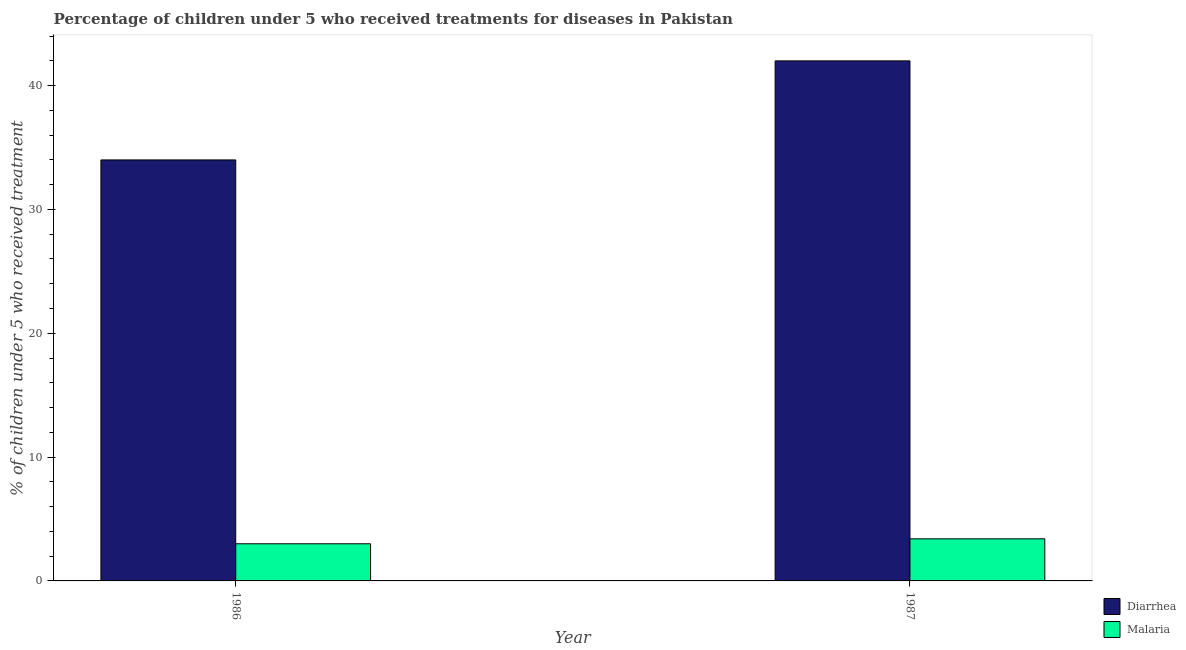Are the number of bars per tick equal to the number of legend labels?
Your answer should be very brief. Yes. Are the number of bars on each tick of the X-axis equal?
Your response must be concise. Yes. What is the label of the 2nd group of bars from the left?
Your answer should be compact. 1987. What is the percentage of children who received treatment for diarrhoea in 1986?
Give a very brief answer. 34. Across all years, what is the maximum percentage of children who received treatment for diarrhoea?
Provide a short and direct response. 42. Across all years, what is the minimum percentage of children who received treatment for diarrhoea?
Your answer should be compact. 34. In which year was the percentage of children who received treatment for malaria minimum?
Your response must be concise. 1986. What is the total percentage of children who received treatment for diarrhoea in the graph?
Make the answer very short. 76. What is the difference between the percentage of children who received treatment for malaria in 1986 and that in 1987?
Provide a short and direct response. -0.4. What is the difference between the percentage of children who received treatment for malaria in 1986 and the percentage of children who received treatment for diarrhoea in 1987?
Provide a succinct answer. -0.4. What is the average percentage of children who received treatment for diarrhoea per year?
Offer a terse response. 38. What is the ratio of the percentage of children who received treatment for diarrhoea in 1986 to that in 1987?
Your answer should be compact. 0.81. Is the percentage of children who received treatment for diarrhoea in 1986 less than that in 1987?
Provide a succinct answer. Yes. What does the 1st bar from the left in 1987 represents?
Offer a very short reply. Diarrhea. What does the 1st bar from the right in 1987 represents?
Provide a short and direct response. Malaria. How many bars are there?
Make the answer very short. 4. Are all the bars in the graph horizontal?
Ensure brevity in your answer.  No. What is the difference between two consecutive major ticks on the Y-axis?
Your answer should be compact. 10. Are the values on the major ticks of Y-axis written in scientific E-notation?
Keep it short and to the point. No. Does the graph contain grids?
Give a very brief answer. No. How many legend labels are there?
Provide a succinct answer. 2. How are the legend labels stacked?
Your answer should be compact. Vertical. What is the title of the graph?
Provide a short and direct response. Percentage of children under 5 who received treatments for diseases in Pakistan. Does "Public credit registry" appear as one of the legend labels in the graph?
Keep it short and to the point. No. What is the label or title of the Y-axis?
Offer a terse response. % of children under 5 who received treatment. What is the % of children under 5 who received treatment in Malaria in 1986?
Your answer should be very brief. 3. What is the % of children under 5 who received treatment in Malaria in 1987?
Give a very brief answer. 3.4. Across all years, what is the maximum % of children under 5 who received treatment in Diarrhea?
Your answer should be compact. 42. Across all years, what is the minimum % of children under 5 who received treatment of Malaria?
Give a very brief answer. 3. What is the total % of children under 5 who received treatment in Malaria in the graph?
Your response must be concise. 6.4. What is the difference between the % of children under 5 who received treatment in Malaria in 1986 and that in 1987?
Provide a short and direct response. -0.4. What is the difference between the % of children under 5 who received treatment in Diarrhea in 1986 and the % of children under 5 who received treatment in Malaria in 1987?
Keep it short and to the point. 30.6. What is the average % of children under 5 who received treatment in Malaria per year?
Offer a very short reply. 3.2. In the year 1986, what is the difference between the % of children under 5 who received treatment of Diarrhea and % of children under 5 who received treatment of Malaria?
Keep it short and to the point. 31. In the year 1987, what is the difference between the % of children under 5 who received treatment in Diarrhea and % of children under 5 who received treatment in Malaria?
Keep it short and to the point. 38.6. What is the ratio of the % of children under 5 who received treatment in Diarrhea in 1986 to that in 1987?
Give a very brief answer. 0.81. What is the ratio of the % of children under 5 who received treatment of Malaria in 1986 to that in 1987?
Your answer should be compact. 0.88. What is the difference between the highest and the lowest % of children under 5 who received treatment in Malaria?
Your answer should be compact. 0.4. 